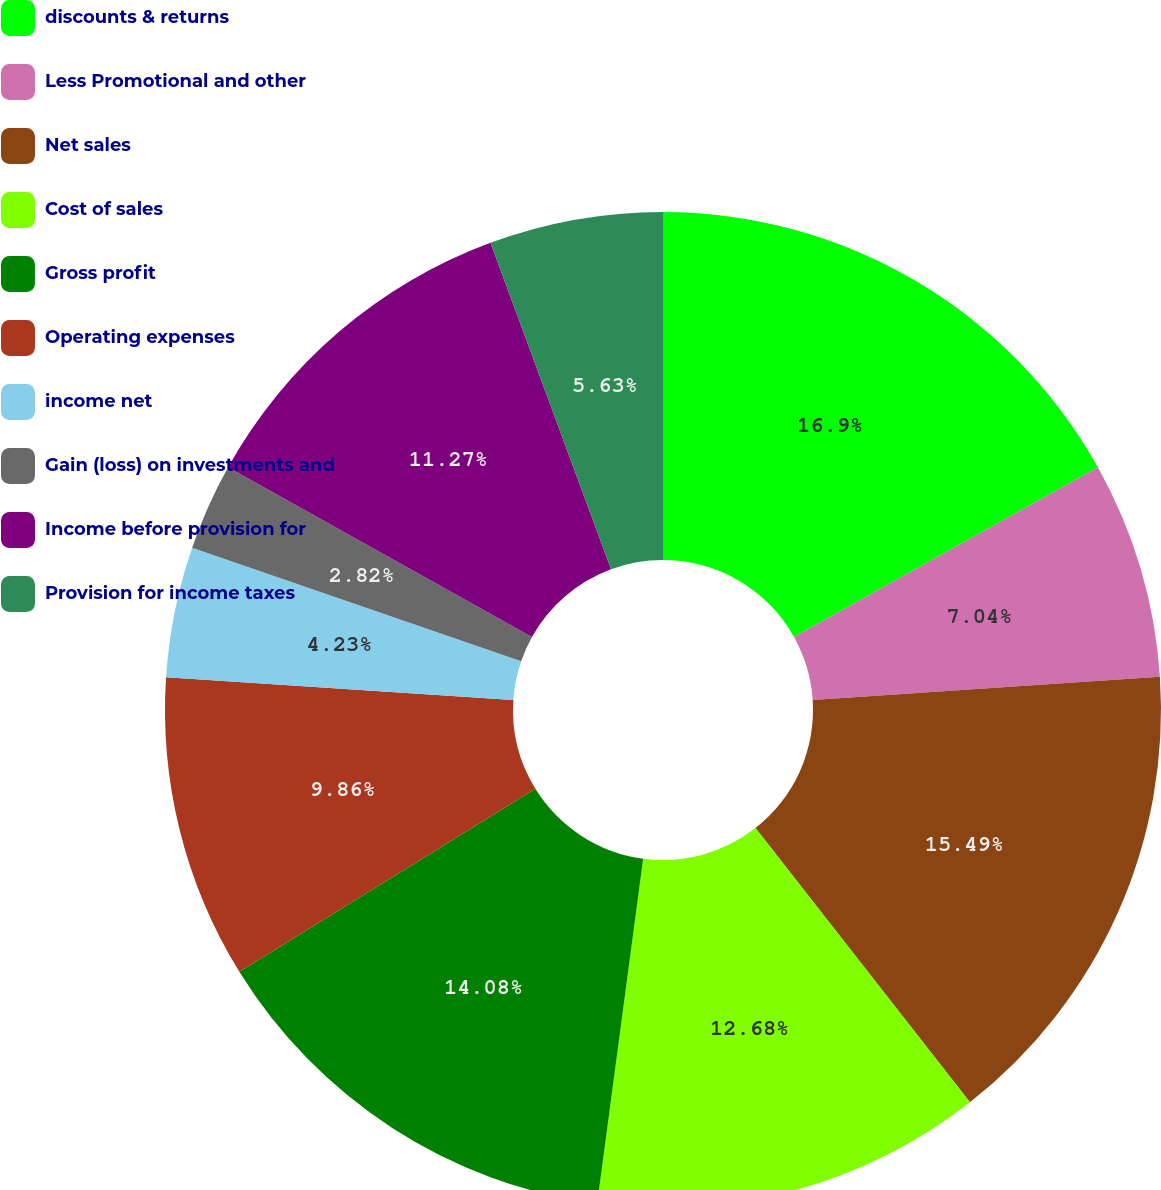<chart> <loc_0><loc_0><loc_500><loc_500><pie_chart><fcel>discounts & returns<fcel>Less Promotional and other<fcel>Net sales<fcel>Cost of sales<fcel>Gross profit<fcel>Operating expenses<fcel>income net<fcel>Gain (loss) on investments and<fcel>Income before provision for<fcel>Provision for income taxes<nl><fcel>16.9%<fcel>7.04%<fcel>15.49%<fcel>12.68%<fcel>14.08%<fcel>9.86%<fcel>4.23%<fcel>2.82%<fcel>11.27%<fcel>5.63%<nl></chart> 